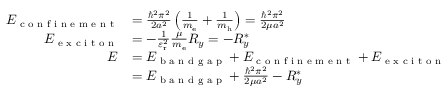<formula> <loc_0><loc_0><loc_500><loc_500>{ \begin{array} { r l } { E _ { c o n f i n e m e n t } } & { = { \frac { \hbar { ^ } { 2 } \pi ^ { 2 } } { 2 a ^ { 2 } } } \left ( { \frac { 1 } { m _ { e } } } + { \frac { 1 } { m _ { h } } } \right ) = { \frac { \hbar { ^ } { 2 } \pi ^ { 2 } } { 2 \mu a ^ { 2 } } } } \\ { E _ { e x c i t o n } } & { = - { \frac { 1 } { \varepsilon _ { r } ^ { 2 } } } { \frac { \mu } { m _ { e } } } R _ { y } = - R _ { y } ^ { * } } \\ { E } & { = E _ { b a n d g a p } + E _ { c o n f i n e m e n t } + E _ { e x c i t o n } } \\ & { = E _ { b a n d g a p } + { \frac { \hbar { ^ } { 2 } \pi ^ { 2 } } { 2 \mu a ^ { 2 } } } - R _ { y } ^ { * } } \end{array} }</formula> 